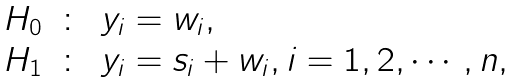Convert formula to latex. <formula><loc_0><loc_0><loc_500><loc_500>\begin{array} { l c l } H _ { 0 } & \colon & y _ { i } = w _ { i } , \\ H _ { 1 } & \colon & y _ { i } = s _ { i } + w _ { i } , i = 1 , 2 , \cdots , n , \\ \end{array}</formula> 